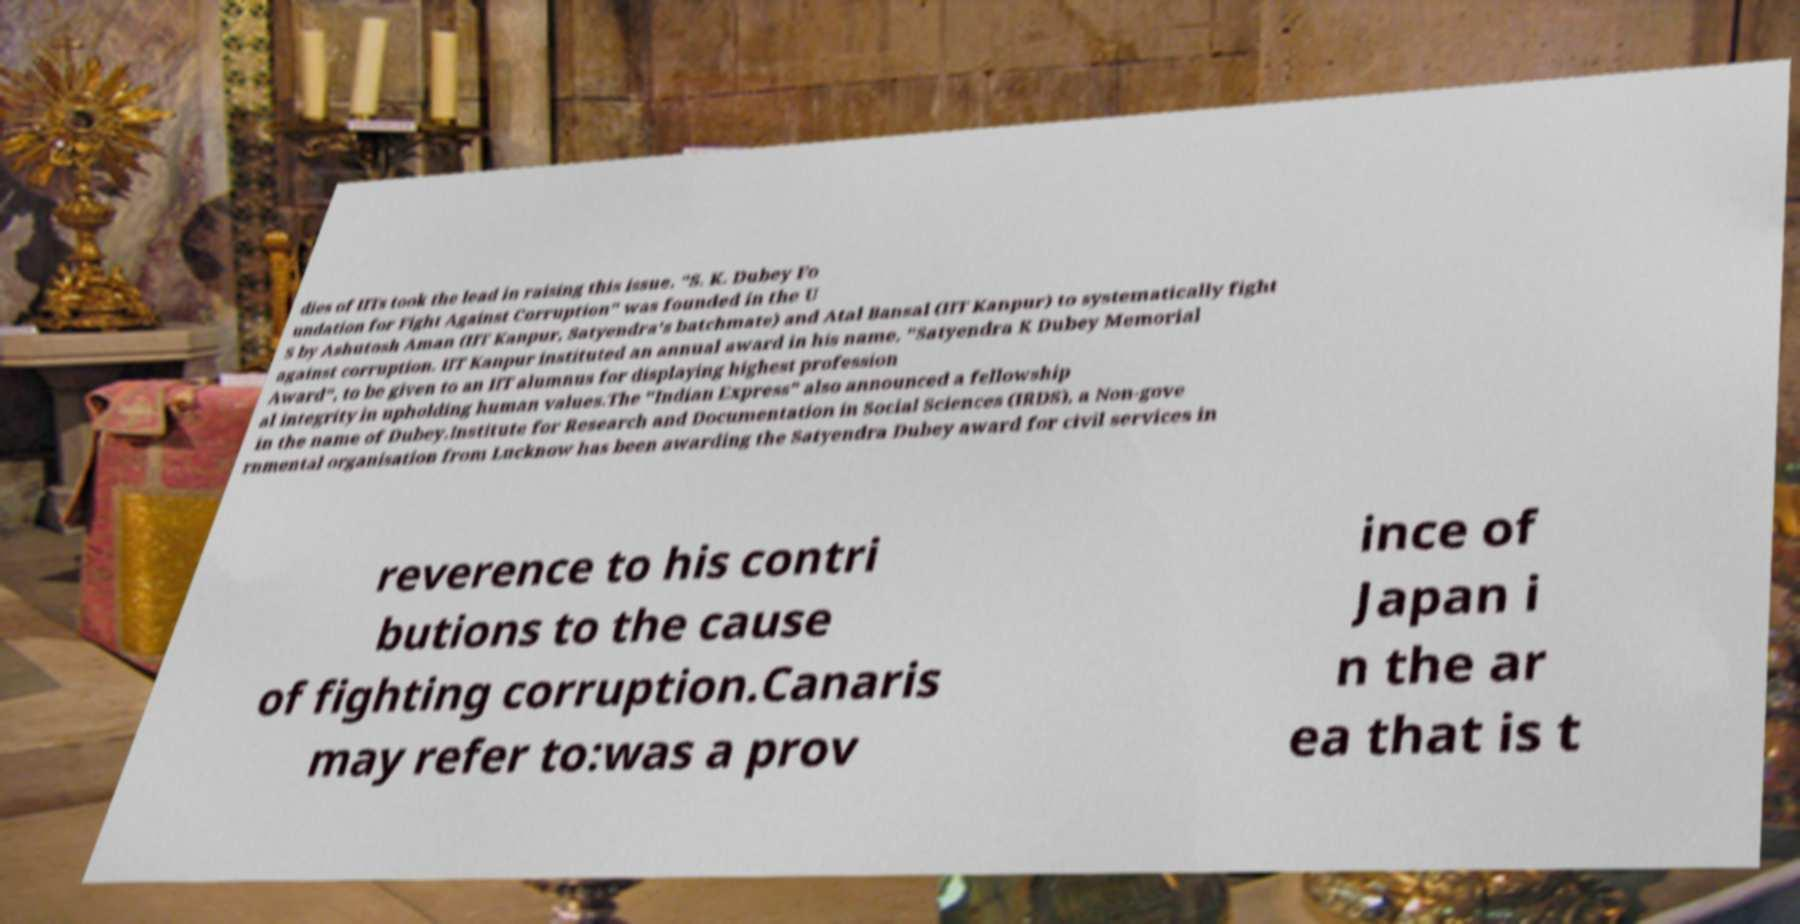I need the written content from this picture converted into text. Can you do that? dies of IITs took the lead in raising this issue. "S. K. Dubey Fo undation for Fight Against Corruption" was founded in the U S by Ashutosh Aman (IIT Kanpur, Satyendra's batchmate) and Atal Bansal (IIT Kanpur) to systematically fight against corruption. IIT Kanpur instituted an annual award in his name, "Satyendra K Dubey Memorial Award", to be given to an IIT alumnus for displaying highest profession al integrity in upholding human values.The "Indian Express" also announced a fellowship in the name of Dubey.Institute for Research and Documentation in Social Sciences (IRDS), a Non-gove rnmental organisation from Lucknow has been awarding the Satyendra Dubey award for civil services in reverence to his contri butions to the cause of fighting corruption.Canaris may refer to:was a prov ince of Japan i n the ar ea that is t 